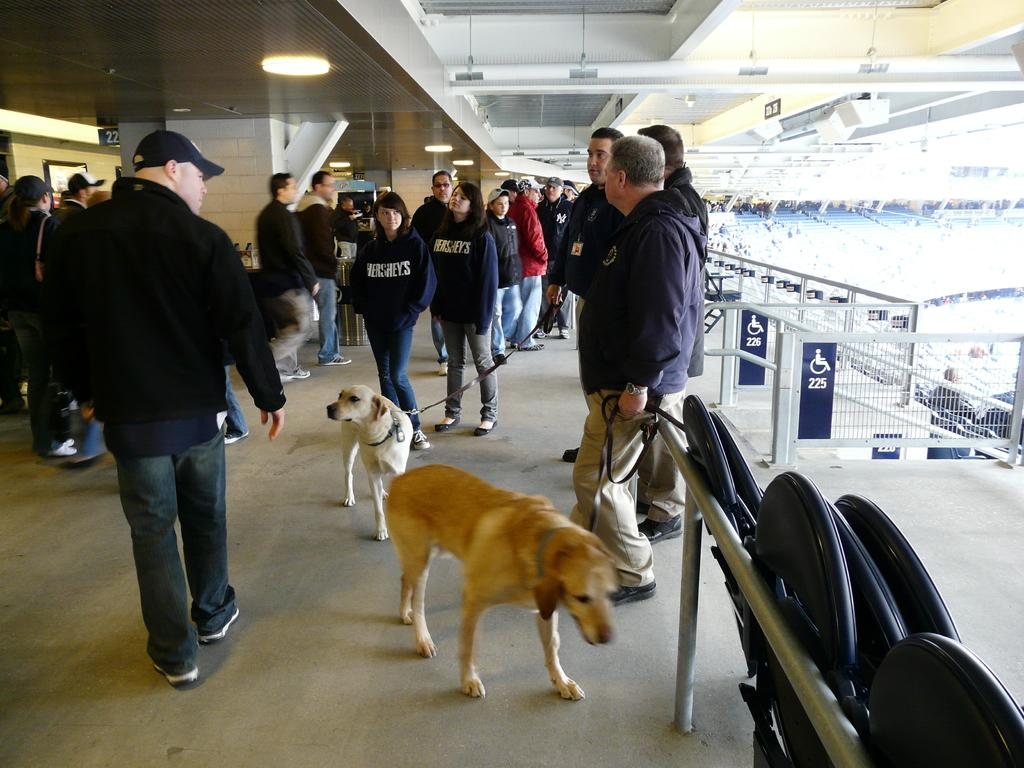What type of location is depicted in the image? The image is of a stadium. What are the people in the image doing? The people in the image are standing on the floor of the stadium. Are there any animals present in the image? Yes, there are dogs in the image. What type of event is taking place in the stadium, and how does the squirrel contribute to it? There is no squirrel present in the image, and no event is mentioned or depicted. 